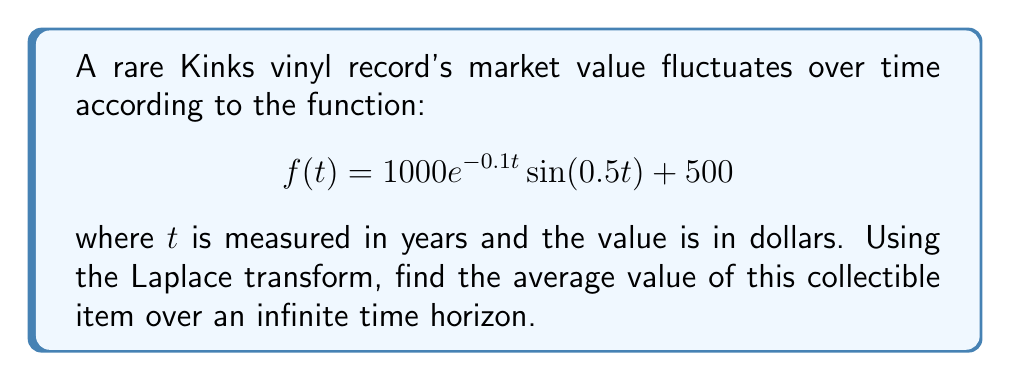Provide a solution to this math problem. To solve this problem, we'll follow these steps:

1) First, recall that the average value over an infinite time horizon is given by the final value theorem:

   $$\lim_{t \to \infty} f(t) = \lim_{s \to 0} sF(s)$$

   where $F(s)$ is the Laplace transform of $f(t)$.

2) Let's find the Laplace transform of $f(t)$. We can split it into two parts:

   $f(t) = 1000e^{-0.1t}\sin(0.5t) + 500$

3) The Laplace transform of a constant is that constant divided by $s$:

   $\mathcal{L}\{500\} = \frac{500}{s}$

4) For the first part, we can use the Laplace transform of a damped sinusoid:

   $\mathcal{L}\{e^{-at}\sin(bt)\} = \frac{b}{(s+a)^2 + b^2}$

   Here, $a = 0.1$ and $b = 0.5$

5) Putting it all together:

   $$F(s) = \frac{1000 \cdot 0.5}{(s+0.1)^2 + 0.5^2} + \frac{500}{s}$$

6) Simplify:

   $$F(s) = \frac{500}{(s+0.1)^2 + 0.25} + \frac{500}{s}$$

7) Now, apply the final value theorem:

   $$\lim_{t \to \infty} f(t) = \lim_{s \to 0} s \left(\frac{500}{(s+0.1)^2 + 0.25} + \frac{500}{s}\right)$$

8) As $s$ approaches 0, the first term goes to 0, and the second term simplifies:

   $$\lim_{s \to 0} s \cdot \frac{500}{s} = 500$$

Therefore, the average value of the collectible over an infinite time horizon is $500.
Answer: $500 